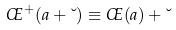Convert formula to latex. <formula><loc_0><loc_0><loc_500><loc_500>\phi ^ { + } ( a + \lambda ) \equiv \phi ( a ) + \lambda</formula> 